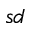<formula> <loc_0><loc_0><loc_500><loc_500>s d</formula> 